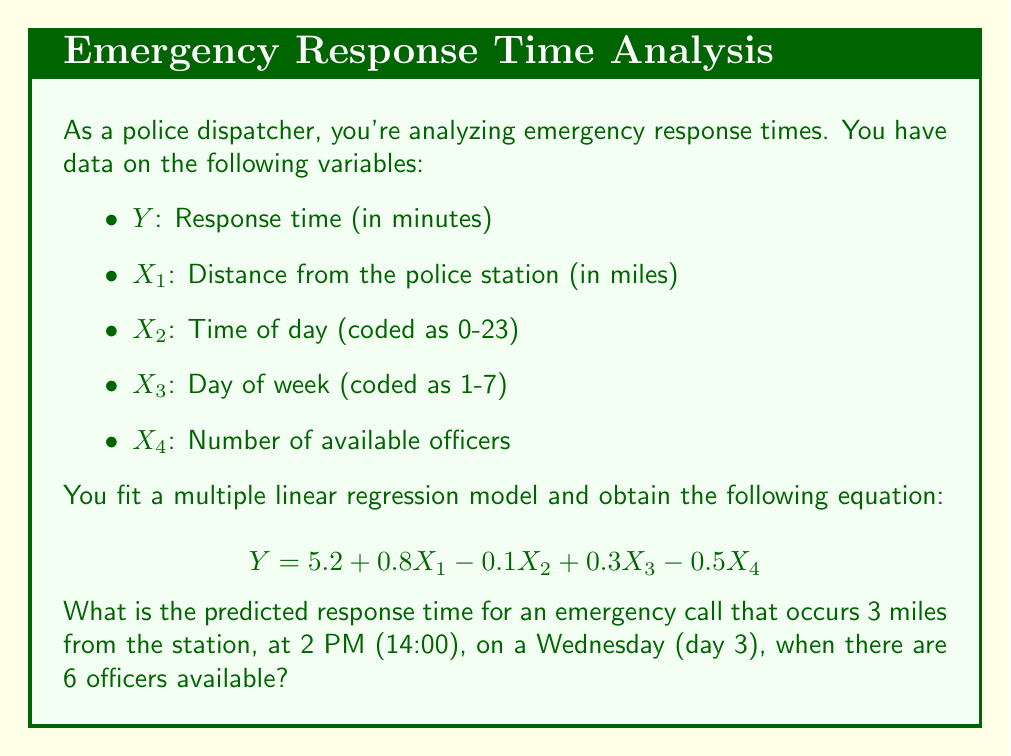Help me with this question. To solve this problem, we need to use the given multiple linear regression equation and substitute the values for each variable. Let's break it down step by step:

1. The regression equation is:
   $$Y = 5.2 + 0.8X_1 - 0.1X_2 + 0.3X_3 - 0.5X_4$$

2. We have the following values:
   - $X_1$ (Distance) = 3 miles
   - $X_2$ (Time of day) = 14 (2 PM)
   - $X_3$ (Day of week) = 3 (Wednesday)
   - $X_4$ (Number of officers) = 6

3. Let's substitute these values into the equation:
   $$Y = 5.2 + 0.8(3) - 0.1(14) + 0.3(3) - 0.5(6)$$

4. Now, let's calculate each term:
   - $5.2$ (constant term)
   - $0.8(3) = 2.4$
   - $-0.1(14) = -1.4$
   - $0.3(3) = 0.9$
   - $-0.5(6) = -3.0$

5. Sum up all the terms:
   $$Y = 5.2 + 2.4 - 1.4 + 0.9 - 3.0$$

6. Perform the final calculation:
   $$Y = 4.1$$

Therefore, the predicted response time is 4.1 minutes.
Answer: 4.1 minutes 